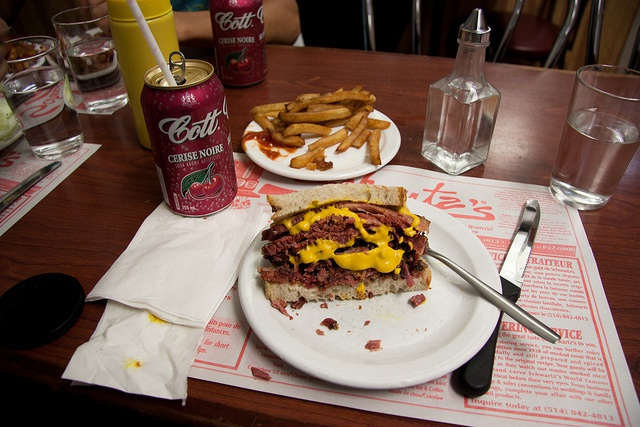Describe the objects in this image and their specific colors. I can see dining table in black, lightgray, maroon, and darkgray tones, cake in black, maroon, orange, and brown tones, sandwich in black, maroon, orange, and brown tones, cup in black, maroon, brown, and gray tones, and bottle in black, brown, maroon, and gray tones in this image. 